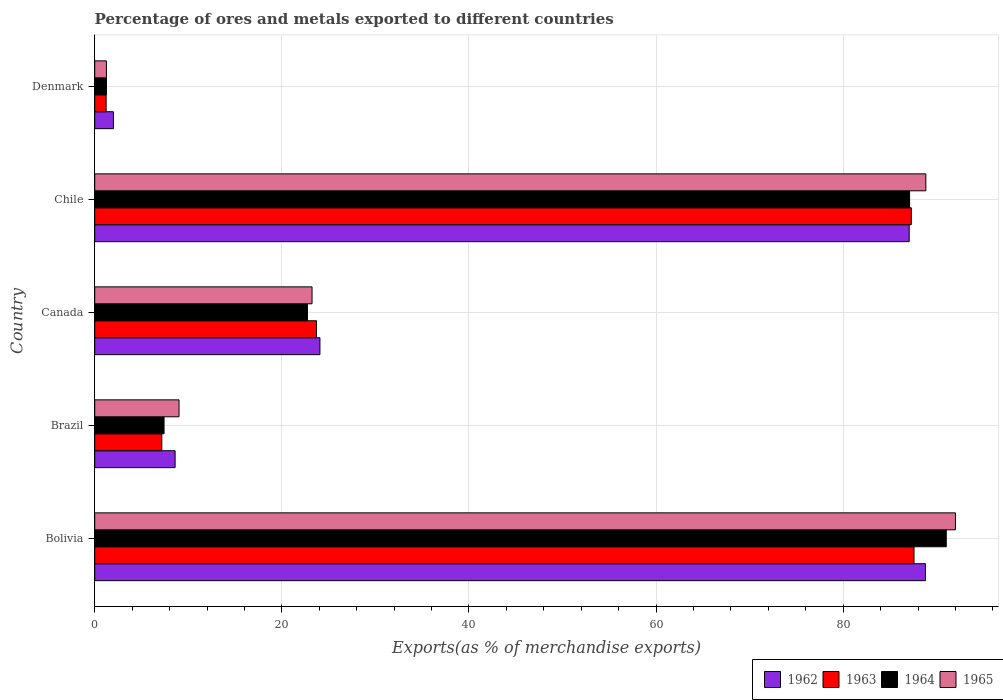How many different coloured bars are there?
Your response must be concise. 4. How many groups of bars are there?
Give a very brief answer. 5. How many bars are there on the 3rd tick from the top?
Your answer should be compact. 4. What is the percentage of exports to different countries in 1964 in Denmark?
Offer a very short reply. 1.25. Across all countries, what is the maximum percentage of exports to different countries in 1963?
Your response must be concise. 87.57. Across all countries, what is the minimum percentage of exports to different countries in 1965?
Offer a terse response. 1.25. In which country was the percentage of exports to different countries in 1962 maximum?
Your answer should be compact. Bolivia. What is the total percentage of exports to different countries in 1962 in the graph?
Provide a succinct answer. 210.51. What is the difference between the percentage of exports to different countries in 1964 in Chile and that in Denmark?
Offer a terse response. 85.84. What is the difference between the percentage of exports to different countries in 1965 in Chile and the percentage of exports to different countries in 1963 in Canada?
Keep it short and to the point. 65.13. What is the average percentage of exports to different countries in 1965 per country?
Your answer should be very brief. 42.86. What is the difference between the percentage of exports to different countries in 1964 and percentage of exports to different countries in 1962 in Chile?
Ensure brevity in your answer.  0.04. What is the ratio of the percentage of exports to different countries in 1962 in Bolivia to that in Brazil?
Ensure brevity in your answer.  10.33. Is the difference between the percentage of exports to different countries in 1964 in Bolivia and Brazil greater than the difference between the percentage of exports to different countries in 1962 in Bolivia and Brazil?
Offer a terse response. Yes. What is the difference between the highest and the second highest percentage of exports to different countries in 1965?
Provide a succinct answer. 3.16. What is the difference between the highest and the lowest percentage of exports to different countries in 1964?
Ensure brevity in your answer.  89.76. Is it the case that in every country, the sum of the percentage of exports to different countries in 1962 and percentage of exports to different countries in 1965 is greater than the sum of percentage of exports to different countries in 1963 and percentage of exports to different countries in 1964?
Keep it short and to the point. No. What does the 4th bar from the top in Bolivia represents?
Make the answer very short. 1962. What does the 4th bar from the bottom in Bolivia represents?
Keep it short and to the point. 1965. Is it the case that in every country, the sum of the percentage of exports to different countries in 1964 and percentage of exports to different countries in 1963 is greater than the percentage of exports to different countries in 1965?
Your answer should be very brief. Yes. Are all the bars in the graph horizontal?
Your answer should be very brief. Yes. How are the legend labels stacked?
Offer a terse response. Horizontal. What is the title of the graph?
Give a very brief answer. Percentage of ores and metals exported to different countries. What is the label or title of the X-axis?
Offer a very short reply. Exports(as % of merchandise exports). What is the label or title of the Y-axis?
Make the answer very short. Country. What is the Exports(as % of merchandise exports) of 1962 in Bolivia?
Give a very brief answer. 88.79. What is the Exports(as % of merchandise exports) of 1963 in Bolivia?
Your response must be concise. 87.57. What is the Exports(as % of merchandise exports) in 1964 in Bolivia?
Make the answer very short. 91.02. What is the Exports(as % of merchandise exports) of 1965 in Bolivia?
Ensure brevity in your answer.  92. What is the Exports(as % of merchandise exports) of 1962 in Brazil?
Provide a succinct answer. 8.59. What is the Exports(as % of merchandise exports) in 1963 in Brazil?
Offer a terse response. 7.17. What is the Exports(as % of merchandise exports) in 1964 in Brazil?
Your answer should be compact. 7.41. What is the Exports(as % of merchandise exports) of 1965 in Brazil?
Ensure brevity in your answer.  9.01. What is the Exports(as % of merchandise exports) of 1962 in Canada?
Your response must be concise. 24.07. What is the Exports(as % of merchandise exports) in 1963 in Canada?
Ensure brevity in your answer.  23.71. What is the Exports(as % of merchandise exports) in 1964 in Canada?
Provide a short and direct response. 22.74. What is the Exports(as % of merchandise exports) in 1965 in Canada?
Give a very brief answer. 23.23. What is the Exports(as % of merchandise exports) of 1962 in Chile?
Provide a succinct answer. 87.06. What is the Exports(as % of merchandise exports) in 1963 in Chile?
Offer a terse response. 87.28. What is the Exports(as % of merchandise exports) in 1964 in Chile?
Provide a short and direct response. 87.1. What is the Exports(as % of merchandise exports) in 1965 in Chile?
Provide a short and direct response. 88.84. What is the Exports(as % of merchandise exports) in 1962 in Denmark?
Offer a very short reply. 2. What is the Exports(as % of merchandise exports) of 1963 in Denmark?
Make the answer very short. 1.22. What is the Exports(as % of merchandise exports) in 1964 in Denmark?
Provide a succinct answer. 1.25. What is the Exports(as % of merchandise exports) of 1965 in Denmark?
Provide a short and direct response. 1.25. Across all countries, what is the maximum Exports(as % of merchandise exports) in 1962?
Ensure brevity in your answer.  88.79. Across all countries, what is the maximum Exports(as % of merchandise exports) of 1963?
Ensure brevity in your answer.  87.57. Across all countries, what is the maximum Exports(as % of merchandise exports) of 1964?
Your answer should be compact. 91.02. Across all countries, what is the maximum Exports(as % of merchandise exports) of 1965?
Keep it short and to the point. 92. Across all countries, what is the minimum Exports(as % of merchandise exports) in 1962?
Keep it short and to the point. 2. Across all countries, what is the minimum Exports(as % of merchandise exports) of 1963?
Provide a succinct answer. 1.22. Across all countries, what is the minimum Exports(as % of merchandise exports) of 1964?
Provide a succinct answer. 1.25. Across all countries, what is the minimum Exports(as % of merchandise exports) in 1965?
Offer a terse response. 1.25. What is the total Exports(as % of merchandise exports) in 1962 in the graph?
Your response must be concise. 210.51. What is the total Exports(as % of merchandise exports) in 1963 in the graph?
Keep it short and to the point. 206.95. What is the total Exports(as % of merchandise exports) of 1964 in the graph?
Your answer should be very brief. 209.51. What is the total Exports(as % of merchandise exports) of 1965 in the graph?
Your response must be concise. 214.32. What is the difference between the Exports(as % of merchandise exports) in 1962 in Bolivia and that in Brazil?
Offer a terse response. 80.2. What is the difference between the Exports(as % of merchandise exports) of 1963 in Bolivia and that in Brazil?
Give a very brief answer. 80.4. What is the difference between the Exports(as % of merchandise exports) in 1964 in Bolivia and that in Brazil?
Your answer should be compact. 83.61. What is the difference between the Exports(as % of merchandise exports) in 1965 in Bolivia and that in Brazil?
Offer a very short reply. 82.99. What is the difference between the Exports(as % of merchandise exports) in 1962 in Bolivia and that in Canada?
Provide a succinct answer. 64.72. What is the difference between the Exports(as % of merchandise exports) in 1963 in Bolivia and that in Canada?
Offer a terse response. 63.86. What is the difference between the Exports(as % of merchandise exports) in 1964 in Bolivia and that in Canada?
Provide a succinct answer. 68.28. What is the difference between the Exports(as % of merchandise exports) of 1965 in Bolivia and that in Canada?
Your answer should be compact. 68.77. What is the difference between the Exports(as % of merchandise exports) in 1962 in Bolivia and that in Chile?
Provide a short and direct response. 1.74. What is the difference between the Exports(as % of merchandise exports) of 1963 in Bolivia and that in Chile?
Keep it short and to the point. 0.29. What is the difference between the Exports(as % of merchandise exports) of 1964 in Bolivia and that in Chile?
Make the answer very short. 3.92. What is the difference between the Exports(as % of merchandise exports) in 1965 in Bolivia and that in Chile?
Your answer should be compact. 3.16. What is the difference between the Exports(as % of merchandise exports) of 1962 in Bolivia and that in Denmark?
Make the answer very short. 86.8. What is the difference between the Exports(as % of merchandise exports) in 1963 in Bolivia and that in Denmark?
Your response must be concise. 86.35. What is the difference between the Exports(as % of merchandise exports) in 1964 in Bolivia and that in Denmark?
Offer a terse response. 89.76. What is the difference between the Exports(as % of merchandise exports) of 1965 in Bolivia and that in Denmark?
Keep it short and to the point. 90.75. What is the difference between the Exports(as % of merchandise exports) in 1962 in Brazil and that in Canada?
Offer a very short reply. -15.48. What is the difference between the Exports(as % of merchandise exports) of 1963 in Brazil and that in Canada?
Give a very brief answer. -16.54. What is the difference between the Exports(as % of merchandise exports) of 1964 in Brazil and that in Canada?
Provide a succinct answer. -15.33. What is the difference between the Exports(as % of merchandise exports) of 1965 in Brazil and that in Canada?
Your answer should be compact. -14.22. What is the difference between the Exports(as % of merchandise exports) in 1962 in Brazil and that in Chile?
Ensure brevity in your answer.  -78.46. What is the difference between the Exports(as % of merchandise exports) in 1963 in Brazil and that in Chile?
Offer a very short reply. -80.11. What is the difference between the Exports(as % of merchandise exports) of 1964 in Brazil and that in Chile?
Ensure brevity in your answer.  -79.69. What is the difference between the Exports(as % of merchandise exports) of 1965 in Brazil and that in Chile?
Provide a succinct answer. -79.83. What is the difference between the Exports(as % of merchandise exports) of 1962 in Brazil and that in Denmark?
Your answer should be compact. 6.59. What is the difference between the Exports(as % of merchandise exports) of 1963 in Brazil and that in Denmark?
Provide a short and direct response. 5.95. What is the difference between the Exports(as % of merchandise exports) in 1964 in Brazil and that in Denmark?
Your response must be concise. 6.15. What is the difference between the Exports(as % of merchandise exports) of 1965 in Brazil and that in Denmark?
Ensure brevity in your answer.  7.76. What is the difference between the Exports(as % of merchandise exports) of 1962 in Canada and that in Chile?
Your answer should be compact. -62.98. What is the difference between the Exports(as % of merchandise exports) in 1963 in Canada and that in Chile?
Your response must be concise. -63.58. What is the difference between the Exports(as % of merchandise exports) of 1964 in Canada and that in Chile?
Give a very brief answer. -64.36. What is the difference between the Exports(as % of merchandise exports) of 1965 in Canada and that in Chile?
Provide a short and direct response. -65.61. What is the difference between the Exports(as % of merchandise exports) in 1962 in Canada and that in Denmark?
Provide a short and direct response. 22.07. What is the difference between the Exports(as % of merchandise exports) of 1963 in Canada and that in Denmark?
Offer a very short reply. 22.49. What is the difference between the Exports(as % of merchandise exports) of 1964 in Canada and that in Denmark?
Offer a terse response. 21.48. What is the difference between the Exports(as % of merchandise exports) of 1965 in Canada and that in Denmark?
Ensure brevity in your answer.  21.98. What is the difference between the Exports(as % of merchandise exports) in 1962 in Chile and that in Denmark?
Keep it short and to the point. 85.06. What is the difference between the Exports(as % of merchandise exports) in 1963 in Chile and that in Denmark?
Provide a short and direct response. 86.06. What is the difference between the Exports(as % of merchandise exports) in 1964 in Chile and that in Denmark?
Give a very brief answer. 85.84. What is the difference between the Exports(as % of merchandise exports) of 1965 in Chile and that in Denmark?
Make the answer very short. 87.58. What is the difference between the Exports(as % of merchandise exports) of 1962 in Bolivia and the Exports(as % of merchandise exports) of 1963 in Brazil?
Provide a short and direct response. 81.62. What is the difference between the Exports(as % of merchandise exports) of 1962 in Bolivia and the Exports(as % of merchandise exports) of 1964 in Brazil?
Make the answer very short. 81.39. What is the difference between the Exports(as % of merchandise exports) of 1962 in Bolivia and the Exports(as % of merchandise exports) of 1965 in Brazil?
Give a very brief answer. 79.78. What is the difference between the Exports(as % of merchandise exports) of 1963 in Bolivia and the Exports(as % of merchandise exports) of 1964 in Brazil?
Your answer should be compact. 80.16. What is the difference between the Exports(as % of merchandise exports) in 1963 in Bolivia and the Exports(as % of merchandise exports) in 1965 in Brazil?
Make the answer very short. 78.56. What is the difference between the Exports(as % of merchandise exports) in 1964 in Bolivia and the Exports(as % of merchandise exports) in 1965 in Brazil?
Provide a succinct answer. 82.01. What is the difference between the Exports(as % of merchandise exports) in 1962 in Bolivia and the Exports(as % of merchandise exports) in 1963 in Canada?
Ensure brevity in your answer.  65.09. What is the difference between the Exports(as % of merchandise exports) of 1962 in Bolivia and the Exports(as % of merchandise exports) of 1964 in Canada?
Offer a very short reply. 66.06. What is the difference between the Exports(as % of merchandise exports) in 1962 in Bolivia and the Exports(as % of merchandise exports) in 1965 in Canada?
Give a very brief answer. 65.57. What is the difference between the Exports(as % of merchandise exports) in 1963 in Bolivia and the Exports(as % of merchandise exports) in 1964 in Canada?
Offer a terse response. 64.83. What is the difference between the Exports(as % of merchandise exports) in 1963 in Bolivia and the Exports(as % of merchandise exports) in 1965 in Canada?
Offer a very short reply. 64.34. What is the difference between the Exports(as % of merchandise exports) of 1964 in Bolivia and the Exports(as % of merchandise exports) of 1965 in Canada?
Provide a short and direct response. 67.79. What is the difference between the Exports(as % of merchandise exports) of 1962 in Bolivia and the Exports(as % of merchandise exports) of 1963 in Chile?
Your answer should be very brief. 1.51. What is the difference between the Exports(as % of merchandise exports) in 1962 in Bolivia and the Exports(as % of merchandise exports) in 1964 in Chile?
Your answer should be very brief. 1.7. What is the difference between the Exports(as % of merchandise exports) in 1962 in Bolivia and the Exports(as % of merchandise exports) in 1965 in Chile?
Offer a terse response. -0.04. What is the difference between the Exports(as % of merchandise exports) of 1963 in Bolivia and the Exports(as % of merchandise exports) of 1964 in Chile?
Make the answer very short. 0.47. What is the difference between the Exports(as % of merchandise exports) in 1963 in Bolivia and the Exports(as % of merchandise exports) in 1965 in Chile?
Your answer should be compact. -1.27. What is the difference between the Exports(as % of merchandise exports) in 1964 in Bolivia and the Exports(as % of merchandise exports) in 1965 in Chile?
Provide a short and direct response. 2.18. What is the difference between the Exports(as % of merchandise exports) of 1962 in Bolivia and the Exports(as % of merchandise exports) of 1963 in Denmark?
Offer a very short reply. 87.57. What is the difference between the Exports(as % of merchandise exports) of 1962 in Bolivia and the Exports(as % of merchandise exports) of 1964 in Denmark?
Your response must be concise. 87.54. What is the difference between the Exports(as % of merchandise exports) of 1962 in Bolivia and the Exports(as % of merchandise exports) of 1965 in Denmark?
Your response must be concise. 87.54. What is the difference between the Exports(as % of merchandise exports) in 1963 in Bolivia and the Exports(as % of merchandise exports) in 1964 in Denmark?
Your answer should be compact. 86.32. What is the difference between the Exports(as % of merchandise exports) in 1963 in Bolivia and the Exports(as % of merchandise exports) in 1965 in Denmark?
Provide a short and direct response. 86.32. What is the difference between the Exports(as % of merchandise exports) in 1964 in Bolivia and the Exports(as % of merchandise exports) in 1965 in Denmark?
Make the answer very short. 89.77. What is the difference between the Exports(as % of merchandise exports) in 1962 in Brazil and the Exports(as % of merchandise exports) in 1963 in Canada?
Ensure brevity in your answer.  -15.11. What is the difference between the Exports(as % of merchandise exports) of 1962 in Brazil and the Exports(as % of merchandise exports) of 1964 in Canada?
Offer a terse response. -14.15. What is the difference between the Exports(as % of merchandise exports) of 1962 in Brazil and the Exports(as % of merchandise exports) of 1965 in Canada?
Give a very brief answer. -14.64. What is the difference between the Exports(as % of merchandise exports) in 1963 in Brazil and the Exports(as % of merchandise exports) in 1964 in Canada?
Your answer should be very brief. -15.57. What is the difference between the Exports(as % of merchandise exports) in 1963 in Brazil and the Exports(as % of merchandise exports) in 1965 in Canada?
Provide a short and direct response. -16.06. What is the difference between the Exports(as % of merchandise exports) of 1964 in Brazil and the Exports(as % of merchandise exports) of 1965 in Canada?
Your answer should be very brief. -15.82. What is the difference between the Exports(as % of merchandise exports) of 1962 in Brazil and the Exports(as % of merchandise exports) of 1963 in Chile?
Offer a terse response. -78.69. What is the difference between the Exports(as % of merchandise exports) in 1962 in Brazil and the Exports(as % of merchandise exports) in 1964 in Chile?
Provide a succinct answer. -78.51. What is the difference between the Exports(as % of merchandise exports) of 1962 in Brazil and the Exports(as % of merchandise exports) of 1965 in Chile?
Keep it short and to the point. -80.24. What is the difference between the Exports(as % of merchandise exports) in 1963 in Brazil and the Exports(as % of merchandise exports) in 1964 in Chile?
Keep it short and to the point. -79.93. What is the difference between the Exports(as % of merchandise exports) of 1963 in Brazil and the Exports(as % of merchandise exports) of 1965 in Chile?
Give a very brief answer. -81.67. What is the difference between the Exports(as % of merchandise exports) of 1964 in Brazil and the Exports(as % of merchandise exports) of 1965 in Chile?
Offer a very short reply. -81.43. What is the difference between the Exports(as % of merchandise exports) of 1962 in Brazil and the Exports(as % of merchandise exports) of 1963 in Denmark?
Offer a terse response. 7.37. What is the difference between the Exports(as % of merchandise exports) in 1962 in Brazil and the Exports(as % of merchandise exports) in 1964 in Denmark?
Provide a short and direct response. 7.34. What is the difference between the Exports(as % of merchandise exports) of 1962 in Brazil and the Exports(as % of merchandise exports) of 1965 in Denmark?
Provide a short and direct response. 7.34. What is the difference between the Exports(as % of merchandise exports) in 1963 in Brazil and the Exports(as % of merchandise exports) in 1964 in Denmark?
Ensure brevity in your answer.  5.92. What is the difference between the Exports(as % of merchandise exports) of 1963 in Brazil and the Exports(as % of merchandise exports) of 1965 in Denmark?
Provide a succinct answer. 5.92. What is the difference between the Exports(as % of merchandise exports) in 1964 in Brazil and the Exports(as % of merchandise exports) in 1965 in Denmark?
Ensure brevity in your answer.  6.16. What is the difference between the Exports(as % of merchandise exports) in 1962 in Canada and the Exports(as % of merchandise exports) in 1963 in Chile?
Your answer should be very brief. -63.21. What is the difference between the Exports(as % of merchandise exports) of 1962 in Canada and the Exports(as % of merchandise exports) of 1964 in Chile?
Offer a terse response. -63.03. What is the difference between the Exports(as % of merchandise exports) of 1962 in Canada and the Exports(as % of merchandise exports) of 1965 in Chile?
Provide a short and direct response. -64.76. What is the difference between the Exports(as % of merchandise exports) in 1963 in Canada and the Exports(as % of merchandise exports) in 1964 in Chile?
Keep it short and to the point. -63.39. What is the difference between the Exports(as % of merchandise exports) of 1963 in Canada and the Exports(as % of merchandise exports) of 1965 in Chile?
Your answer should be very brief. -65.13. What is the difference between the Exports(as % of merchandise exports) of 1964 in Canada and the Exports(as % of merchandise exports) of 1965 in Chile?
Offer a very short reply. -66.1. What is the difference between the Exports(as % of merchandise exports) of 1962 in Canada and the Exports(as % of merchandise exports) of 1963 in Denmark?
Give a very brief answer. 22.85. What is the difference between the Exports(as % of merchandise exports) of 1962 in Canada and the Exports(as % of merchandise exports) of 1964 in Denmark?
Provide a short and direct response. 22.82. What is the difference between the Exports(as % of merchandise exports) in 1962 in Canada and the Exports(as % of merchandise exports) in 1965 in Denmark?
Your response must be concise. 22.82. What is the difference between the Exports(as % of merchandise exports) of 1963 in Canada and the Exports(as % of merchandise exports) of 1964 in Denmark?
Offer a terse response. 22.45. What is the difference between the Exports(as % of merchandise exports) of 1963 in Canada and the Exports(as % of merchandise exports) of 1965 in Denmark?
Your answer should be very brief. 22.45. What is the difference between the Exports(as % of merchandise exports) of 1964 in Canada and the Exports(as % of merchandise exports) of 1965 in Denmark?
Provide a succinct answer. 21.49. What is the difference between the Exports(as % of merchandise exports) of 1962 in Chile and the Exports(as % of merchandise exports) of 1963 in Denmark?
Give a very brief answer. 85.84. What is the difference between the Exports(as % of merchandise exports) in 1962 in Chile and the Exports(as % of merchandise exports) in 1964 in Denmark?
Provide a short and direct response. 85.8. What is the difference between the Exports(as % of merchandise exports) of 1962 in Chile and the Exports(as % of merchandise exports) of 1965 in Denmark?
Ensure brevity in your answer.  85.8. What is the difference between the Exports(as % of merchandise exports) in 1963 in Chile and the Exports(as % of merchandise exports) in 1964 in Denmark?
Ensure brevity in your answer.  86.03. What is the difference between the Exports(as % of merchandise exports) of 1963 in Chile and the Exports(as % of merchandise exports) of 1965 in Denmark?
Ensure brevity in your answer.  86.03. What is the difference between the Exports(as % of merchandise exports) of 1964 in Chile and the Exports(as % of merchandise exports) of 1965 in Denmark?
Provide a succinct answer. 85.85. What is the average Exports(as % of merchandise exports) of 1962 per country?
Your answer should be compact. 42.1. What is the average Exports(as % of merchandise exports) in 1963 per country?
Offer a terse response. 41.39. What is the average Exports(as % of merchandise exports) of 1964 per country?
Your answer should be very brief. 41.9. What is the average Exports(as % of merchandise exports) of 1965 per country?
Offer a very short reply. 42.86. What is the difference between the Exports(as % of merchandise exports) of 1962 and Exports(as % of merchandise exports) of 1963 in Bolivia?
Your answer should be very brief. 1.22. What is the difference between the Exports(as % of merchandise exports) in 1962 and Exports(as % of merchandise exports) in 1964 in Bolivia?
Keep it short and to the point. -2.22. What is the difference between the Exports(as % of merchandise exports) in 1962 and Exports(as % of merchandise exports) in 1965 in Bolivia?
Provide a short and direct response. -3.21. What is the difference between the Exports(as % of merchandise exports) of 1963 and Exports(as % of merchandise exports) of 1964 in Bolivia?
Your response must be concise. -3.45. What is the difference between the Exports(as % of merchandise exports) in 1963 and Exports(as % of merchandise exports) in 1965 in Bolivia?
Give a very brief answer. -4.43. What is the difference between the Exports(as % of merchandise exports) of 1964 and Exports(as % of merchandise exports) of 1965 in Bolivia?
Make the answer very short. -0.98. What is the difference between the Exports(as % of merchandise exports) of 1962 and Exports(as % of merchandise exports) of 1963 in Brazil?
Offer a terse response. 1.42. What is the difference between the Exports(as % of merchandise exports) in 1962 and Exports(as % of merchandise exports) in 1964 in Brazil?
Your answer should be very brief. 1.18. What is the difference between the Exports(as % of merchandise exports) of 1962 and Exports(as % of merchandise exports) of 1965 in Brazil?
Provide a succinct answer. -0.42. What is the difference between the Exports(as % of merchandise exports) of 1963 and Exports(as % of merchandise exports) of 1964 in Brazil?
Your response must be concise. -0.24. What is the difference between the Exports(as % of merchandise exports) in 1963 and Exports(as % of merchandise exports) in 1965 in Brazil?
Offer a very short reply. -1.84. What is the difference between the Exports(as % of merchandise exports) of 1964 and Exports(as % of merchandise exports) of 1965 in Brazil?
Your answer should be very brief. -1.6. What is the difference between the Exports(as % of merchandise exports) of 1962 and Exports(as % of merchandise exports) of 1963 in Canada?
Your answer should be compact. 0.37. What is the difference between the Exports(as % of merchandise exports) in 1962 and Exports(as % of merchandise exports) in 1964 in Canada?
Provide a short and direct response. 1.33. What is the difference between the Exports(as % of merchandise exports) of 1962 and Exports(as % of merchandise exports) of 1965 in Canada?
Your response must be concise. 0.84. What is the difference between the Exports(as % of merchandise exports) of 1963 and Exports(as % of merchandise exports) of 1964 in Canada?
Your answer should be very brief. 0.97. What is the difference between the Exports(as % of merchandise exports) of 1963 and Exports(as % of merchandise exports) of 1965 in Canada?
Ensure brevity in your answer.  0.48. What is the difference between the Exports(as % of merchandise exports) of 1964 and Exports(as % of merchandise exports) of 1965 in Canada?
Provide a succinct answer. -0.49. What is the difference between the Exports(as % of merchandise exports) of 1962 and Exports(as % of merchandise exports) of 1963 in Chile?
Give a very brief answer. -0.23. What is the difference between the Exports(as % of merchandise exports) of 1962 and Exports(as % of merchandise exports) of 1964 in Chile?
Offer a terse response. -0.04. What is the difference between the Exports(as % of merchandise exports) of 1962 and Exports(as % of merchandise exports) of 1965 in Chile?
Offer a very short reply. -1.78. What is the difference between the Exports(as % of merchandise exports) in 1963 and Exports(as % of merchandise exports) in 1964 in Chile?
Keep it short and to the point. 0.18. What is the difference between the Exports(as % of merchandise exports) in 1963 and Exports(as % of merchandise exports) in 1965 in Chile?
Provide a succinct answer. -1.55. What is the difference between the Exports(as % of merchandise exports) in 1964 and Exports(as % of merchandise exports) in 1965 in Chile?
Provide a succinct answer. -1.74. What is the difference between the Exports(as % of merchandise exports) of 1962 and Exports(as % of merchandise exports) of 1963 in Denmark?
Give a very brief answer. 0.78. What is the difference between the Exports(as % of merchandise exports) in 1962 and Exports(as % of merchandise exports) in 1964 in Denmark?
Your answer should be very brief. 0.74. What is the difference between the Exports(as % of merchandise exports) of 1962 and Exports(as % of merchandise exports) of 1965 in Denmark?
Provide a short and direct response. 0.75. What is the difference between the Exports(as % of merchandise exports) in 1963 and Exports(as % of merchandise exports) in 1964 in Denmark?
Provide a short and direct response. -0.03. What is the difference between the Exports(as % of merchandise exports) of 1963 and Exports(as % of merchandise exports) of 1965 in Denmark?
Keep it short and to the point. -0.03. What is the difference between the Exports(as % of merchandise exports) in 1964 and Exports(as % of merchandise exports) in 1965 in Denmark?
Your response must be concise. 0. What is the ratio of the Exports(as % of merchandise exports) in 1962 in Bolivia to that in Brazil?
Your response must be concise. 10.33. What is the ratio of the Exports(as % of merchandise exports) in 1963 in Bolivia to that in Brazil?
Ensure brevity in your answer.  12.21. What is the ratio of the Exports(as % of merchandise exports) in 1964 in Bolivia to that in Brazil?
Provide a succinct answer. 12.29. What is the ratio of the Exports(as % of merchandise exports) in 1965 in Bolivia to that in Brazil?
Ensure brevity in your answer.  10.21. What is the ratio of the Exports(as % of merchandise exports) in 1962 in Bolivia to that in Canada?
Make the answer very short. 3.69. What is the ratio of the Exports(as % of merchandise exports) of 1963 in Bolivia to that in Canada?
Give a very brief answer. 3.69. What is the ratio of the Exports(as % of merchandise exports) in 1964 in Bolivia to that in Canada?
Offer a very short reply. 4. What is the ratio of the Exports(as % of merchandise exports) in 1965 in Bolivia to that in Canada?
Offer a very short reply. 3.96. What is the ratio of the Exports(as % of merchandise exports) of 1962 in Bolivia to that in Chile?
Ensure brevity in your answer.  1.02. What is the ratio of the Exports(as % of merchandise exports) in 1964 in Bolivia to that in Chile?
Your answer should be compact. 1.04. What is the ratio of the Exports(as % of merchandise exports) of 1965 in Bolivia to that in Chile?
Offer a very short reply. 1.04. What is the ratio of the Exports(as % of merchandise exports) in 1962 in Bolivia to that in Denmark?
Provide a succinct answer. 44.45. What is the ratio of the Exports(as % of merchandise exports) of 1963 in Bolivia to that in Denmark?
Keep it short and to the point. 71.8. What is the ratio of the Exports(as % of merchandise exports) in 1964 in Bolivia to that in Denmark?
Provide a succinct answer. 72.57. What is the ratio of the Exports(as % of merchandise exports) of 1965 in Bolivia to that in Denmark?
Ensure brevity in your answer.  73.53. What is the ratio of the Exports(as % of merchandise exports) of 1962 in Brazil to that in Canada?
Your answer should be compact. 0.36. What is the ratio of the Exports(as % of merchandise exports) in 1963 in Brazil to that in Canada?
Make the answer very short. 0.3. What is the ratio of the Exports(as % of merchandise exports) of 1964 in Brazil to that in Canada?
Keep it short and to the point. 0.33. What is the ratio of the Exports(as % of merchandise exports) of 1965 in Brazil to that in Canada?
Ensure brevity in your answer.  0.39. What is the ratio of the Exports(as % of merchandise exports) of 1962 in Brazil to that in Chile?
Ensure brevity in your answer.  0.1. What is the ratio of the Exports(as % of merchandise exports) in 1963 in Brazil to that in Chile?
Your answer should be compact. 0.08. What is the ratio of the Exports(as % of merchandise exports) in 1964 in Brazil to that in Chile?
Make the answer very short. 0.09. What is the ratio of the Exports(as % of merchandise exports) in 1965 in Brazil to that in Chile?
Offer a terse response. 0.1. What is the ratio of the Exports(as % of merchandise exports) of 1962 in Brazil to that in Denmark?
Offer a terse response. 4.3. What is the ratio of the Exports(as % of merchandise exports) in 1963 in Brazil to that in Denmark?
Your response must be concise. 5.88. What is the ratio of the Exports(as % of merchandise exports) in 1964 in Brazil to that in Denmark?
Your response must be concise. 5.91. What is the ratio of the Exports(as % of merchandise exports) of 1965 in Brazil to that in Denmark?
Offer a terse response. 7.2. What is the ratio of the Exports(as % of merchandise exports) in 1962 in Canada to that in Chile?
Give a very brief answer. 0.28. What is the ratio of the Exports(as % of merchandise exports) in 1963 in Canada to that in Chile?
Your response must be concise. 0.27. What is the ratio of the Exports(as % of merchandise exports) of 1964 in Canada to that in Chile?
Provide a short and direct response. 0.26. What is the ratio of the Exports(as % of merchandise exports) in 1965 in Canada to that in Chile?
Ensure brevity in your answer.  0.26. What is the ratio of the Exports(as % of merchandise exports) of 1962 in Canada to that in Denmark?
Give a very brief answer. 12.05. What is the ratio of the Exports(as % of merchandise exports) of 1963 in Canada to that in Denmark?
Your response must be concise. 19.44. What is the ratio of the Exports(as % of merchandise exports) in 1964 in Canada to that in Denmark?
Give a very brief answer. 18.13. What is the ratio of the Exports(as % of merchandise exports) of 1965 in Canada to that in Denmark?
Make the answer very short. 18.56. What is the ratio of the Exports(as % of merchandise exports) of 1962 in Chile to that in Denmark?
Provide a short and direct response. 43.58. What is the ratio of the Exports(as % of merchandise exports) of 1963 in Chile to that in Denmark?
Your answer should be very brief. 71.57. What is the ratio of the Exports(as % of merchandise exports) of 1964 in Chile to that in Denmark?
Offer a terse response. 69.44. What is the ratio of the Exports(as % of merchandise exports) in 1965 in Chile to that in Denmark?
Your answer should be very brief. 71. What is the difference between the highest and the second highest Exports(as % of merchandise exports) in 1962?
Give a very brief answer. 1.74. What is the difference between the highest and the second highest Exports(as % of merchandise exports) of 1963?
Make the answer very short. 0.29. What is the difference between the highest and the second highest Exports(as % of merchandise exports) of 1964?
Your response must be concise. 3.92. What is the difference between the highest and the second highest Exports(as % of merchandise exports) in 1965?
Provide a short and direct response. 3.16. What is the difference between the highest and the lowest Exports(as % of merchandise exports) in 1962?
Offer a terse response. 86.8. What is the difference between the highest and the lowest Exports(as % of merchandise exports) in 1963?
Keep it short and to the point. 86.35. What is the difference between the highest and the lowest Exports(as % of merchandise exports) of 1964?
Ensure brevity in your answer.  89.76. What is the difference between the highest and the lowest Exports(as % of merchandise exports) in 1965?
Give a very brief answer. 90.75. 